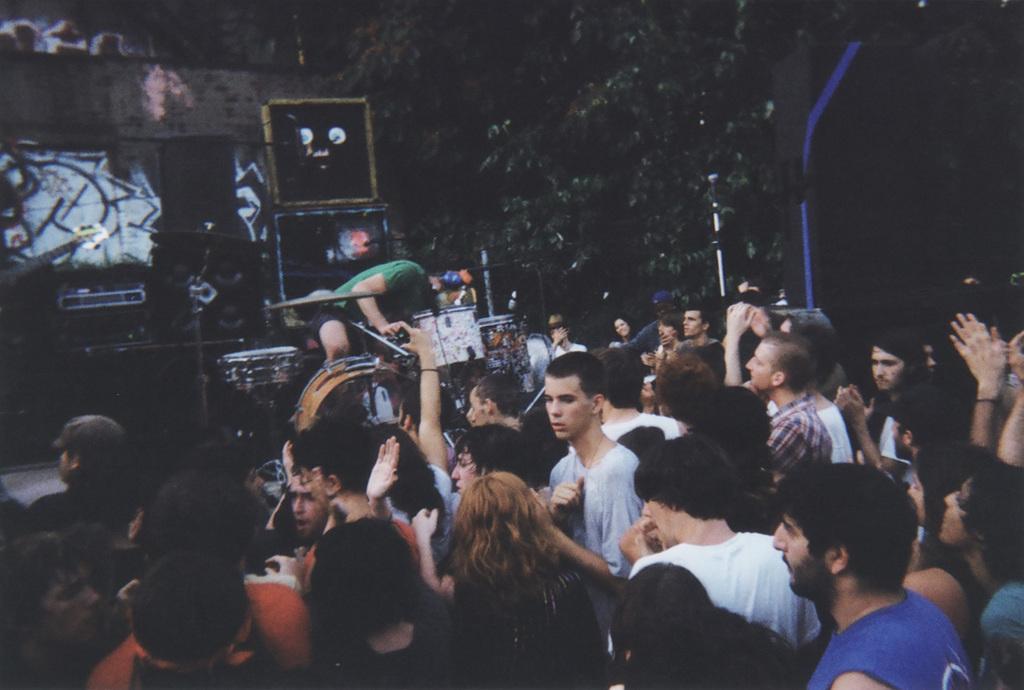Please provide a concise description of this image. In the image I can see a person who is playing the drums on the dais and around there are some other people and some musical instruments. 